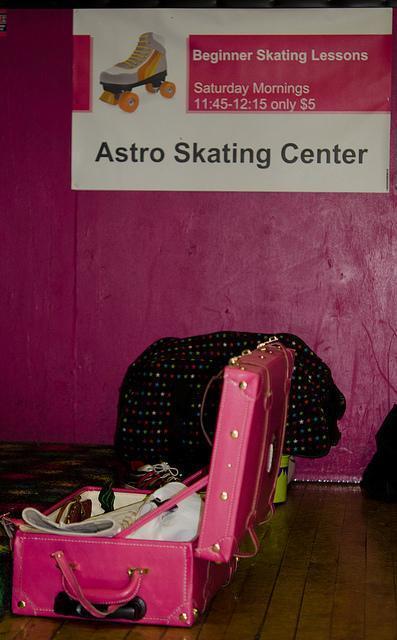How many suitcases?
Give a very brief answer. 1. How many suitcases are there?
Give a very brief answer. 1. How many sets of suitcases are there?
Give a very brief answer. 1. 